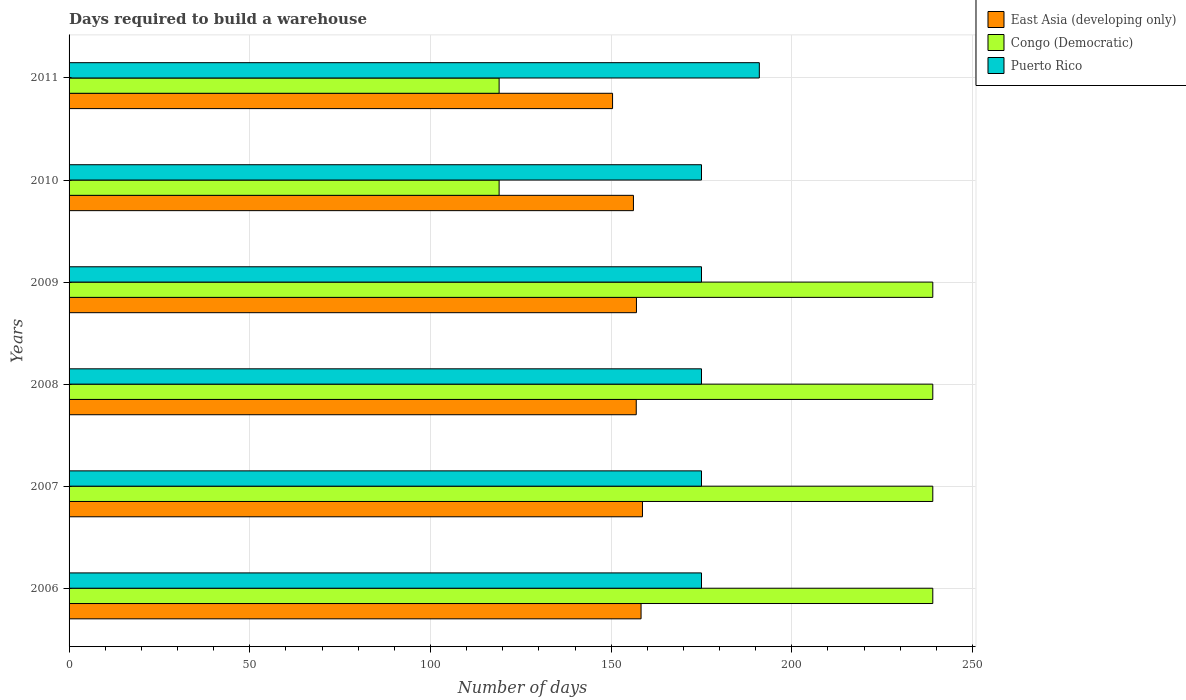How many different coloured bars are there?
Offer a terse response. 3. How many groups of bars are there?
Give a very brief answer. 6. Are the number of bars on each tick of the Y-axis equal?
Keep it short and to the point. Yes. How many bars are there on the 3rd tick from the top?
Provide a short and direct response. 3. What is the label of the 1st group of bars from the top?
Make the answer very short. 2011. What is the days required to build a warehouse in in Puerto Rico in 2006?
Your answer should be very brief. 175. Across all years, what is the maximum days required to build a warehouse in in East Asia (developing only)?
Your answer should be compact. 158.67. Across all years, what is the minimum days required to build a warehouse in in Congo (Democratic)?
Provide a short and direct response. 119. In which year was the days required to build a warehouse in in East Asia (developing only) maximum?
Your answer should be very brief. 2007. What is the total days required to build a warehouse in in Congo (Democratic) in the graph?
Offer a very short reply. 1194. What is the difference between the days required to build a warehouse in in Puerto Rico in 2009 and that in 2011?
Offer a very short reply. -16. What is the difference between the days required to build a warehouse in in Puerto Rico in 2006 and the days required to build a warehouse in in East Asia (developing only) in 2011?
Ensure brevity in your answer.  24.61. What is the average days required to build a warehouse in in Congo (Democratic) per year?
Offer a terse response. 199. In how many years, is the days required to build a warehouse in in East Asia (developing only) greater than 200 days?
Your response must be concise. 0. What is the ratio of the days required to build a warehouse in in Congo (Democratic) in 2007 to that in 2009?
Make the answer very short. 1. What is the difference between the highest and the second highest days required to build a warehouse in in East Asia (developing only)?
Ensure brevity in your answer.  0.39. What is the difference between the highest and the lowest days required to build a warehouse in in East Asia (developing only)?
Keep it short and to the point. 8.28. In how many years, is the days required to build a warehouse in in East Asia (developing only) greater than the average days required to build a warehouse in in East Asia (developing only) taken over all years?
Keep it short and to the point. 4. What does the 1st bar from the top in 2007 represents?
Your answer should be compact. Puerto Rico. What does the 2nd bar from the bottom in 2008 represents?
Your answer should be compact. Congo (Democratic). Is it the case that in every year, the sum of the days required to build a warehouse in in East Asia (developing only) and days required to build a warehouse in in Puerto Rico is greater than the days required to build a warehouse in in Congo (Democratic)?
Ensure brevity in your answer.  Yes. Are all the bars in the graph horizontal?
Ensure brevity in your answer.  Yes. How many years are there in the graph?
Provide a short and direct response. 6. What is the difference between two consecutive major ticks on the X-axis?
Your response must be concise. 50. Are the values on the major ticks of X-axis written in scientific E-notation?
Provide a succinct answer. No. Where does the legend appear in the graph?
Keep it short and to the point. Top right. How many legend labels are there?
Ensure brevity in your answer.  3. How are the legend labels stacked?
Keep it short and to the point. Vertical. What is the title of the graph?
Ensure brevity in your answer.  Days required to build a warehouse. Does "Mauritius" appear as one of the legend labels in the graph?
Offer a very short reply. No. What is the label or title of the X-axis?
Keep it short and to the point. Number of days. What is the label or title of the Y-axis?
Ensure brevity in your answer.  Years. What is the Number of days in East Asia (developing only) in 2006?
Provide a succinct answer. 158.28. What is the Number of days of Congo (Democratic) in 2006?
Give a very brief answer. 239. What is the Number of days in Puerto Rico in 2006?
Your answer should be very brief. 175. What is the Number of days of East Asia (developing only) in 2007?
Ensure brevity in your answer.  158.67. What is the Number of days in Congo (Democratic) in 2007?
Make the answer very short. 239. What is the Number of days of Puerto Rico in 2007?
Provide a succinct answer. 175. What is the Number of days of East Asia (developing only) in 2008?
Provide a short and direct response. 156.94. What is the Number of days in Congo (Democratic) in 2008?
Your response must be concise. 239. What is the Number of days in Puerto Rico in 2008?
Offer a very short reply. 175. What is the Number of days in East Asia (developing only) in 2009?
Keep it short and to the point. 157. What is the Number of days of Congo (Democratic) in 2009?
Ensure brevity in your answer.  239. What is the Number of days of Puerto Rico in 2009?
Ensure brevity in your answer.  175. What is the Number of days in East Asia (developing only) in 2010?
Offer a very short reply. 156.17. What is the Number of days in Congo (Democratic) in 2010?
Ensure brevity in your answer.  119. What is the Number of days in Puerto Rico in 2010?
Provide a short and direct response. 175. What is the Number of days in East Asia (developing only) in 2011?
Your answer should be very brief. 150.39. What is the Number of days in Congo (Democratic) in 2011?
Ensure brevity in your answer.  119. What is the Number of days of Puerto Rico in 2011?
Offer a terse response. 191. Across all years, what is the maximum Number of days of East Asia (developing only)?
Provide a short and direct response. 158.67. Across all years, what is the maximum Number of days of Congo (Democratic)?
Provide a succinct answer. 239. Across all years, what is the maximum Number of days of Puerto Rico?
Your answer should be compact. 191. Across all years, what is the minimum Number of days of East Asia (developing only)?
Offer a very short reply. 150.39. Across all years, what is the minimum Number of days of Congo (Democratic)?
Offer a very short reply. 119. Across all years, what is the minimum Number of days in Puerto Rico?
Ensure brevity in your answer.  175. What is the total Number of days of East Asia (developing only) in the graph?
Keep it short and to the point. 937.44. What is the total Number of days of Congo (Democratic) in the graph?
Provide a succinct answer. 1194. What is the total Number of days of Puerto Rico in the graph?
Your answer should be very brief. 1066. What is the difference between the Number of days in East Asia (developing only) in 2006 and that in 2007?
Make the answer very short. -0.39. What is the difference between the Number of days of Congo (Democratic) in 2006 and that in 2007?
Provide a short and direct response. 0. What is the difference between the Number of days in Puerto Rico in 2006 and that in 2007?
Your answer should be compact. 0. What is the difference between the Number of days of East Asia (developing only) in 2006 and that in 2008?
Make the answer very short. 1.33. What is the difference between the Number of days of Congo (Democratic) in 2006 and that in 2008?
Keep it short and to the point. 0. What is the difference between the Number of days of East Asia (developing only) in 2006 and that in 2009?
Give a very brief answer. 1.28. What is the difference between the Number of days of Congo (Democratic) in 2006 and that in 2009?
Make the answer very short. 0. What is the difference between the Number of days in East Asia (developing only) in 2006 and that in 2010?
Your answer should be compact. 2.11. What is the difference between the Number of days of Congo (Democratic) in 2006 and that in 2010?
Offer a very short reply. 120. What is the difference between the Number of days of Puerto Rico in 2006 and that in 2010?
Provide a succinct answer. 0. What is the difference between the Number of days in East Asia (developing only) in 2006 and that in 2011?
Your answer should be very brief. 7.89. What is the difference between the Number of days of Congo (Democratic) in 2006 and that in 2011?
Your answer should be compact. 120. What is the difference between the Number of days of Puerto Rico in 2006 and that in 2011?
Keep it short and to the point. -16. What is the difference between the Number of days of East Asia (developing only) in 2007 and that in 2008?
Offer a terse response. 1.72. What is the difference between the Number of days of Congo (Democratic) in 2007 and that in 2008?
Provide a succinct answer. 0. What is the difference between the Number of days in East Asia (developing only) in 2007 and that in 2009?
Offer a terse response. 1.67. What is the difference between the Number of days in Puerto Rico in 2007 and that in 2009?
Keep it short and to the point. 0. What is the difference between the Number of days of East Asia (developing only) in 2007 and that in 2010?
Keep it short and to the point. 2.5. What is the difference between the Number of days in Congo (Democratic) in 2007 and that in 2010?
Your answer should be very brief. 120. What is the difference between the Number of days in East Asia (developing only) in 2007 and that in 2011?
Your answer should be compact. 8.28. What is the difference between the Number of days of Congo (Democratic) in 2007 and that in 2011?
Offer a terse response. 120. What is the difference between the Number of days of East Asia (developing only) in 2008 and that in 2009?
Your answer should be compact. -0.06. What is the difference between the Number of days of Puerto Rico in 2008 and that in 2009?
Keep it short and to the point. 0. What is the difference between the Number of days in Congo (Democratic) in 2008 and that in 2010?
Your response must be concise. 120. What is the difference between the Number of days of Puerto Rico in 2008 and that in 2010?
Your response must be concise. 0. What is the difference between the Number of days of East Asia (developing only) in 2008 and that in 2011?
Your answer should be very brief. 6.56. What is the difference between the Number of days of Congo (Democratic) in 2008 and that in 2011?
Keep it short and to the point. 120. What is the difference between the Number of days in Puerto Rico in 2008 and that in 2011?
Your response must be concise. -16. What is the difference between the Number of days of East Asia (developing only) in 2009 and that in 2010?
Ensure brevity in your answer.  0.83. What is the difference between the Number of days of Congo (Democratic) in 2009 and that in 2010?
Your response must be concise. 120. What is the difference between the Number of days in East Asia (developing only) in 2009 and that in 2011?
Keep it short and to the point. 6.61. What is the difference between the Number of days in Congo (Democratic) in 2009 and that in 2011?
Make the answer very short. 120. What is the difference between the Number of days in Puerto Rico in 2009 and that in 2011?
Offer a very short reply. -16. What is the difference between the Number of days of East Asia (developing only) in 2010 and that in 2011?
Your answer should be very brief. 5.78. What is the difference between the Number of days of East Asia (developing only) in 2006 and the Number of days of Congo (Democratic) in 2007?
Provide a succinct answer. -80.72. What is the difference between the Number of days in East Asia (developing only) in 2006 and the Number of days in Puerto Rico in 2007?
Your answer should be compact. -16.72. What is the difference between the Number of days in Congo (Democratic) in 2006 and the Number of days in Puerto Rico in 2007?
Your answer should be compact. 64. What is the difference between the Number of days of East Asia (developing only) in 2006 and the Number of days of Congo (Democratic) in 2008?
Give a very brief answer. -80.72. What is the difference between the Number of days in East Asia (developing only) in 2006 and the Number of days in Puerto Rico in 2008?
Provide a short and direct response. -16.72. What is the difference between the Number of days of Congo (Democratic) in 2006 and the Number of days of Puerto Rico in 2008?
Give a very brief answer. 64. What is the difference between the Number of days of East Asia (developing only) in 2006 and the Number of days of Congo (Democratic) in 2009?
Ensure brevity in your answer.  -80.72. What is the difference between the Number of days in East Asia (developing only) in 2006 and the Number of days in Puerto Rico in 2009?
Give a very brief answer. -16.72. What is the difference between the Number of days in Congo (Democratic) in 2006 and the Number of days in Puerto Rico in 2009?
Offer a very short reply. 64. What is the difference between the Number of days of East Asia (developing only) in 2006 and the Number of days of Congo (Democratic) in 2010?
Provide a short and direct response. 39.28. What is the difference between the Number of days in East Asia (developing only) in 2006 and the Number of days in Puerto Rico in 2010?
Ensure brevity in your answer.  -16.72. What is the difference between the Number of days in East Asia (developing only) in 2006 and the Number of days in Congo (Democratic) in 2011?
Ensure brevity in your answer.  39.28. What is the difference between the Number of days in East Asia (developing only) in 2006 and the Number of days in Puerto Rico in 2011?
Ensure brevity in your answer.  -32.72. What is the difference between the Number of days of Congo (Democratic) in 2006 and the Number of days of Puerto Rico in 2011?
Provide a succinct answer. 48. What is the difference between the Number of days of East Asia (developing only) in 2007 and the Number of days of Congo (Democratic) in 2008?
Offer a terse response. -80.33. What is the difference between the Number of days in East Asia (developing only) in 2007 and the Number of days in Puerto Rico in 2008?
Offer a very short reply. -16.33. What is the difference between the Number of days in East Asia (developing only) in 2007 and the Number of days in Congo (Democratic) in 2009?
Provide a short and direct response. -80.33. What is the difference between the Number of days in East Asia (developing only) in 2007 and the Number of days in Puerto Rico in 2009?
Provide a succinct answer. -16.33. What is the difference between the Number of days of Congo (Democratic) in 2007 and the Number of days of Puerto Rico in 2009?
Keep it short and to the point. 64. What is the difference between the Number of days in East Asia (developing only) in 2007 and the Number of days in Congo (Democratic) in 2010?
Offer a very short reply. 39.67. What is the difference between the Number of days in East Asia (developing only) in 2007 and the Number of days in Puerto Rico in 2010?
Your answer should be very brief. -16.33. What is the difference between the Number of days in Congo (Democratic) in 2007 and the Number of days in Puerto Rico in 2010?
Ensure brevity in your answer.  64. What is the difference between the Number of days of East Asia (developing only) in 2007 and the Number of days of Congo (Democratic) in 2011?
Make the answer very short. 39.67. What is the difference between the Number of days in East Asia (developing only) in 2007 and the Number of days in Puerto Rico in 2011?
Keep it short and to the point. -32.33. What is the difference between the Number of days in East Asia (developing only) in 2008 and the Number of days in Congo (Democratic) in 2009?
Your answer should be very brief. -82.06. What is the difference between the Number of days of East Asia (developing only) in 2008 and the Number of days of Puerto Rico in 2009?
Your answer should be compact. -18.06. What is the difference between the Number of days in Congo (Democratic) in 2008 and the Number of days in Puerto Rico in 2009?
Your answer should be very brief. 64. What is the difference between the Number of days in East Asia (developing only) in 2008 and the Number of days in Congo (Democratic) in 2010?
Provide a short and direct response. 37.94. What is the difference between the Number of days in East Asia (developing only) in 2008 and the Number of days in Puerto Rico in 2010?
Make the answer very short. -18.06. What is the difference between the Number of days in East Asia (developing only) in 2008 and the Number of days in Congo (Democratic) in 2011?
Your answer should be very brief. 37.94. What is the difference between the Number of days of East Asia (developing only) in 2008 and the Number of days of Puerto Rico in 2011?
Keep it short and to the point. -34.06. What is the difference between the Number of days in East Asia (developing only) in 2009 and the Number of days in Puerto Rico in 2010?
Provide a succinct answer. -18. What is the difference between the Number of days in East Asia (developing only) in 2009 and the Number of days in Congo (Democratic) in 2011?
Give a very brief answer. 38. What is the difference between the Number of days of East Asia (developing only) in 2009 and the Number of days of Puerto Rico in 2011?
Give a very brief answer. -34. What is the difference between the Number of days of East Asia (developing only) in 2010 and the Number of days of Congo (Democratic) in 2011?
Provide a succinct answer. 37.17. What is the difference between the Number of days in East Asia (developing only) in 2010 and the Number of days in Puerto Rico in 2011?
Keep it short and to the point. -34.83. What is the difference between the Number of days of Congo (Democratic) in 2010 and the Number of days of Puerto Rico in 2011?
Your answer should be compact. -72. What is the average Number of days of East Asia (developing only) per year?
Your response must be concise. 156.24. What is the average Number of days of Congo (Democratic) per year?
Provide a short and direct response. 199. What is the average Number of days of Puerto Rico per year?
Offer a very short reply. 177.67. In the year 2006, what is the difference between the Number of days of East Asia (developing only) and Number of days of Congo (Democratic)?
Offer a terse response. -80.72. In the year 2006, what is the difference between the Number of days in East Asia (developing only) and Number of days in Puerto Rico?
Your response must be concise. -16.72. In the year 2006, what is the difference between the Number of days of Congo (Democratic) and Number of days of Puerto Rico?
Offer a very short reply. 64. In the year 2007, what is the difference between the Number of days in East Asia (developing only) and Number of days in Congo (Democratic)?
Your answer should be very brief. -80.33. In the year 2007, what is the difference between the Number of days of East Asia (developing only) and Number of days of Puerto Rico?
Offer a very short reply. -16.33. In the year 2007, what is the difference between the Number of days of Congo (Democratic) and Number of days of Puerto Rico?
Keep it short and to the point. 64. In the year 2008, what is the difference between the Number of days in East Asia (developing only) and Number of days in Congo (Democratic)?
Offer a terse response. -82.06. In the year 2008, what is the difference between the Number of days of East Asia (developing only) and Number of days of Puerto Rico?
Provide a succinct answer. -18.06. In the year 2008, what is the difference between the Number of days of Congo (Democratic) and Number of days of Puerto Rico?
Provide a succinct answer. 64. In the year 2009, what is the difference between the Number of days in East Asia (developing only) and Number of days in Congo (Democratic)?
Keep it short and to the point. -82. In the year 2009, what is the difference between the Number of days in East Asia (developing only) and Number of days in Puerto Rico?
Provide a short and direct response. -18. In the year 2009, what is the difference between the Number of days in Congo (Democratic) and Number of days in Puerto Rico?
Give a very brief answer. 64. In the year 2010, what is the difference between the Number of days in East Asia (developing only) and Number of days in Congo (Democratic)?
Make the answer very short. 37.17. In the year 2010, what is the difference between the Number of days of East Asia (developing only) and Number of days of Puerto Rico?
Offer a terse response. -18.83. In the year 2010, what is the difference between the Number of days in Congo (Democratic) and Number of days in Puerto Rico?
Keep it short and to the point. -56. In the year 2011, what is the difference between the Number of days of East Asia (developing only) and Number of days of Congo (Democratic)?
Provide a short and direct response. 31.39. In the year 2011, what is the difference between the Number of days in East Asia (developing only) and Number of days in Puerto Rico?
Your answer should be very brief. -40.61. In the year 2011, what is the difference between the Number of days of Congo (Democratic) and Number of days of Puerto Rico?
Provide a short and direct response. -72. What is the ratio of the Number of days in East Asia (developing only) in 2006 to that in 2007?
Make the answer very short. 1. What is the ratio of the Number of days in Puerto Rico in 2006 to that in 2007?
Make the answer very short. 1. What is the ratio of the Number of days of East Asia (developing only) in 2006 to that in 2008?
Ensure brevity in your answer.  1.01. What is the ratio of the Number of days in Puerto Rico in 2006 to that in 2009?
Your response must be concise. 1. What is the ratio of the Number of days in East Asia (developing only) in 2006 to that in 2010?
Give a very brief answer. 1.01. What is the ratio of the Number of days in Congo (Democratic) in 2006 to that in 2010?
Your answer should be compact. 2.01. What is the ratio of the Number of days in East Asia (developing only) in 2006 to that in 2011?
Provide a succinct answer. 1.05. What is the ratio of the Number of days of Congo (Democratic) in 2006 to that in 2011?
Ensure brevity in your answer.  2.01. What is the ratio of the Number of days of Puerto Rico in 2006 to that in 2011?
Your answer should be compact. 0.92. What is the ratio of the Number of days of Congo (Democratic) in 2007 to that in 2008?
Offer a terse response. 1. What is the ratio of the Number of days in East Asia (developing only) in 2007 to that in 2009?
Ensure brevity in your answer.  1.01. What is the ratio of the Number of days of Congo (Democratic) in 2007 to that in 2010?
Your answer should be compact. 2.01. What is the ratio of the Number of days in Puerto Rico in 2007 to that in 2010?
Give a very brief answer. 1. What is the ratio of the Number of days of East Asia (developing only) in 2007 to that in 2011?
Provide a succinct answer. 1.05. What is the ratio of the Number of days of Congo (Democratic) in 2007 to that in 2011?
Your answer should be very brief. 2.01. What is the ratio of the Number of days of Puerto Rico in 2007 to that in 2011?
Your answer should be compact. 0.92. What is the ratio of the Number of days of Puerto Rico in 2008 to that in 2009?
Ensure brevity in your answer.  1. What is the ratio of the Number of days of East Asia (developing only) in 2008 to that in 2010?
Give a very brief answer. 1. What is the ratio of the Number of days in Congo (Democratic) in 2008 to that in 2010?
Provide a short and direct response. 2.01. What is the ratio of the Number of days in Puerto Rico in 2008 to that in 2010?
Your answer should be very brief. 1. What is the ratio of the Number of days in East Asia (developing only) in 2008 to that in 2011?
Provide a short and direct response. 1.04. What is the ratio of the Number of days in Congo (Democratic) in 2008 to that in 2011?
Ensure brevity in your answer.  2.01. What is the ratio of the Number of days of Puerto Rico in 2008 to that in 2011?
Give a very brief answer. 0.92. What is the ratio of the Number of days of East Asia (developing only) in 2009 to that in 2010?
Provide a succinct answer. 1.01. What is the ratio of the Number of days in Congo (Democratic) in 2009 to that in 2010?
Ensure brevity in your answer.  2.01. What is the ratio of the Number of days of East Asia (developing only) in 2009 to that in 2011?
Your answer should be compact. 1.04. What is the ratio of the Number of days of Congo (Democratic) in 2009 to that in 2011?
Offer a very short reply. 2.01. What is the ratio of the Number of days of Puerto Rico in 2009 to that in 2011?
Give a very brief answer. 0.92. What is the ratio of the Number of days in East Asia (developing only) in 2010 to that in 2011?
Give a very brief answer. 1.04. What is the ratio of the Number of days in Puerto Rico in 2010 to that in 2011?
Ensure brevity in your answer.  0.92. What is the difference between the highest and the second highest Number of days in East Asia (developing only)?
Provide a short and direct response. 0.39. What is the difference between the highest and the lowest Number of days in East Asia (developing only)?
Your answer should be compact. 8.28. What is the difference between the highest and the lowest Number of days of Congo (Democratic)?
Keep it short and to the point. 120. What is the difference between the highest and the lowest Number of days in Puerto Rico?
Your answer should be very brief. 16. 